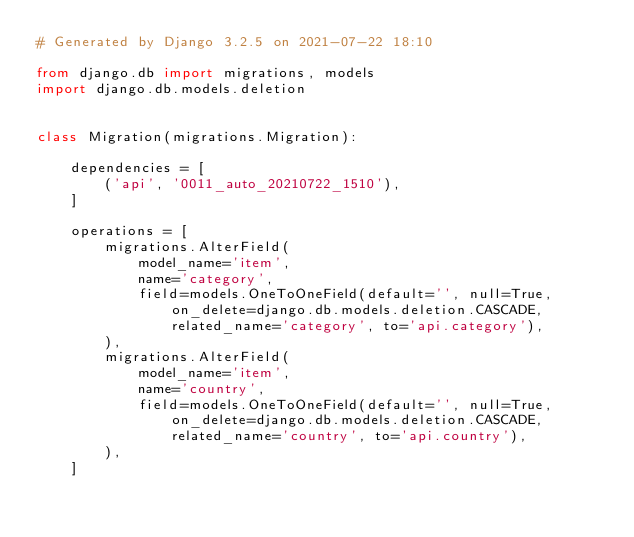Convert code to text. <code><loc_0><loc_0><loc_500><loc_500><_Python_># Generated by Django 3.2.5 on 2021-07-22 18:10

from django.db import migrations, models
import django.db.models.deletion


class Migration(migrations.Migration):

    dependencies = [
        ('api', '0011_auto_20210722_1510'),
    ]

    operations = [
        migrations.AlterField(
            model_name='item',
            name='category',
            field=models.OneToOneField(default='', null=True, on_delete=django.db.models.deletion.CASCADE, related_name='category', to='api.category'),
        ),
        migrations.AlterField(
            model_name='item',
            name='country',
            field=models.OneToOneField(default='', null=True, on_delete=django.db.models.deletion.CASCADE, related_name='country', to='api.country'),
        ),
    ]
</code> 